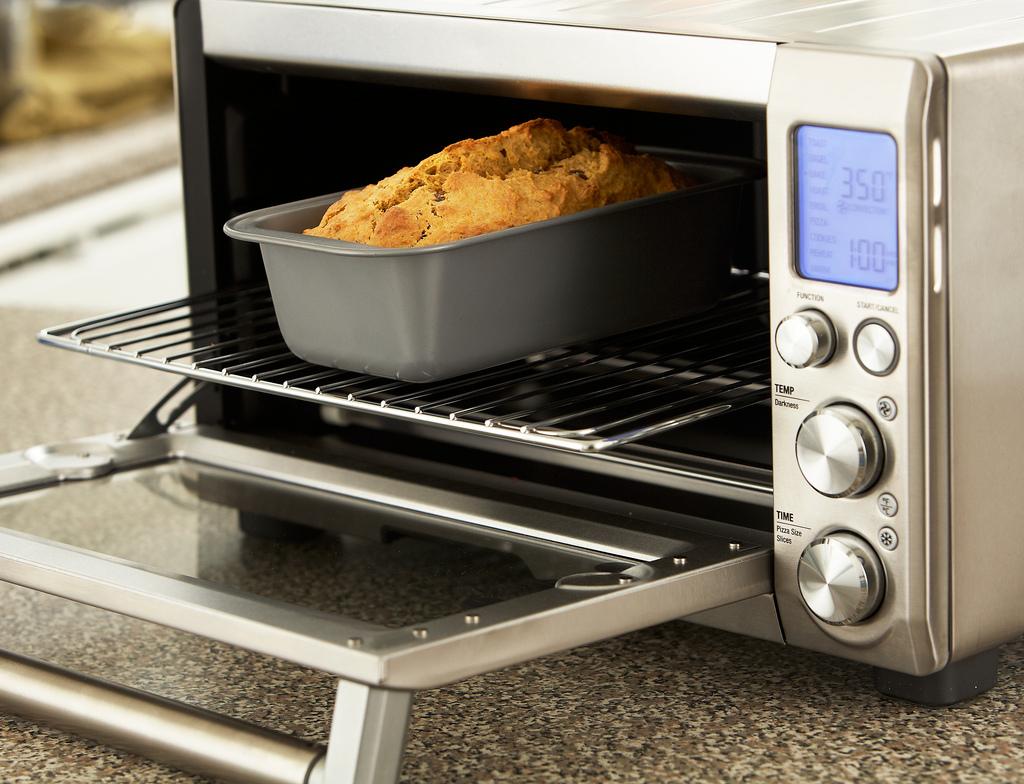Microwave is good or bad?
Ensure brevity in your answer.  Good. 